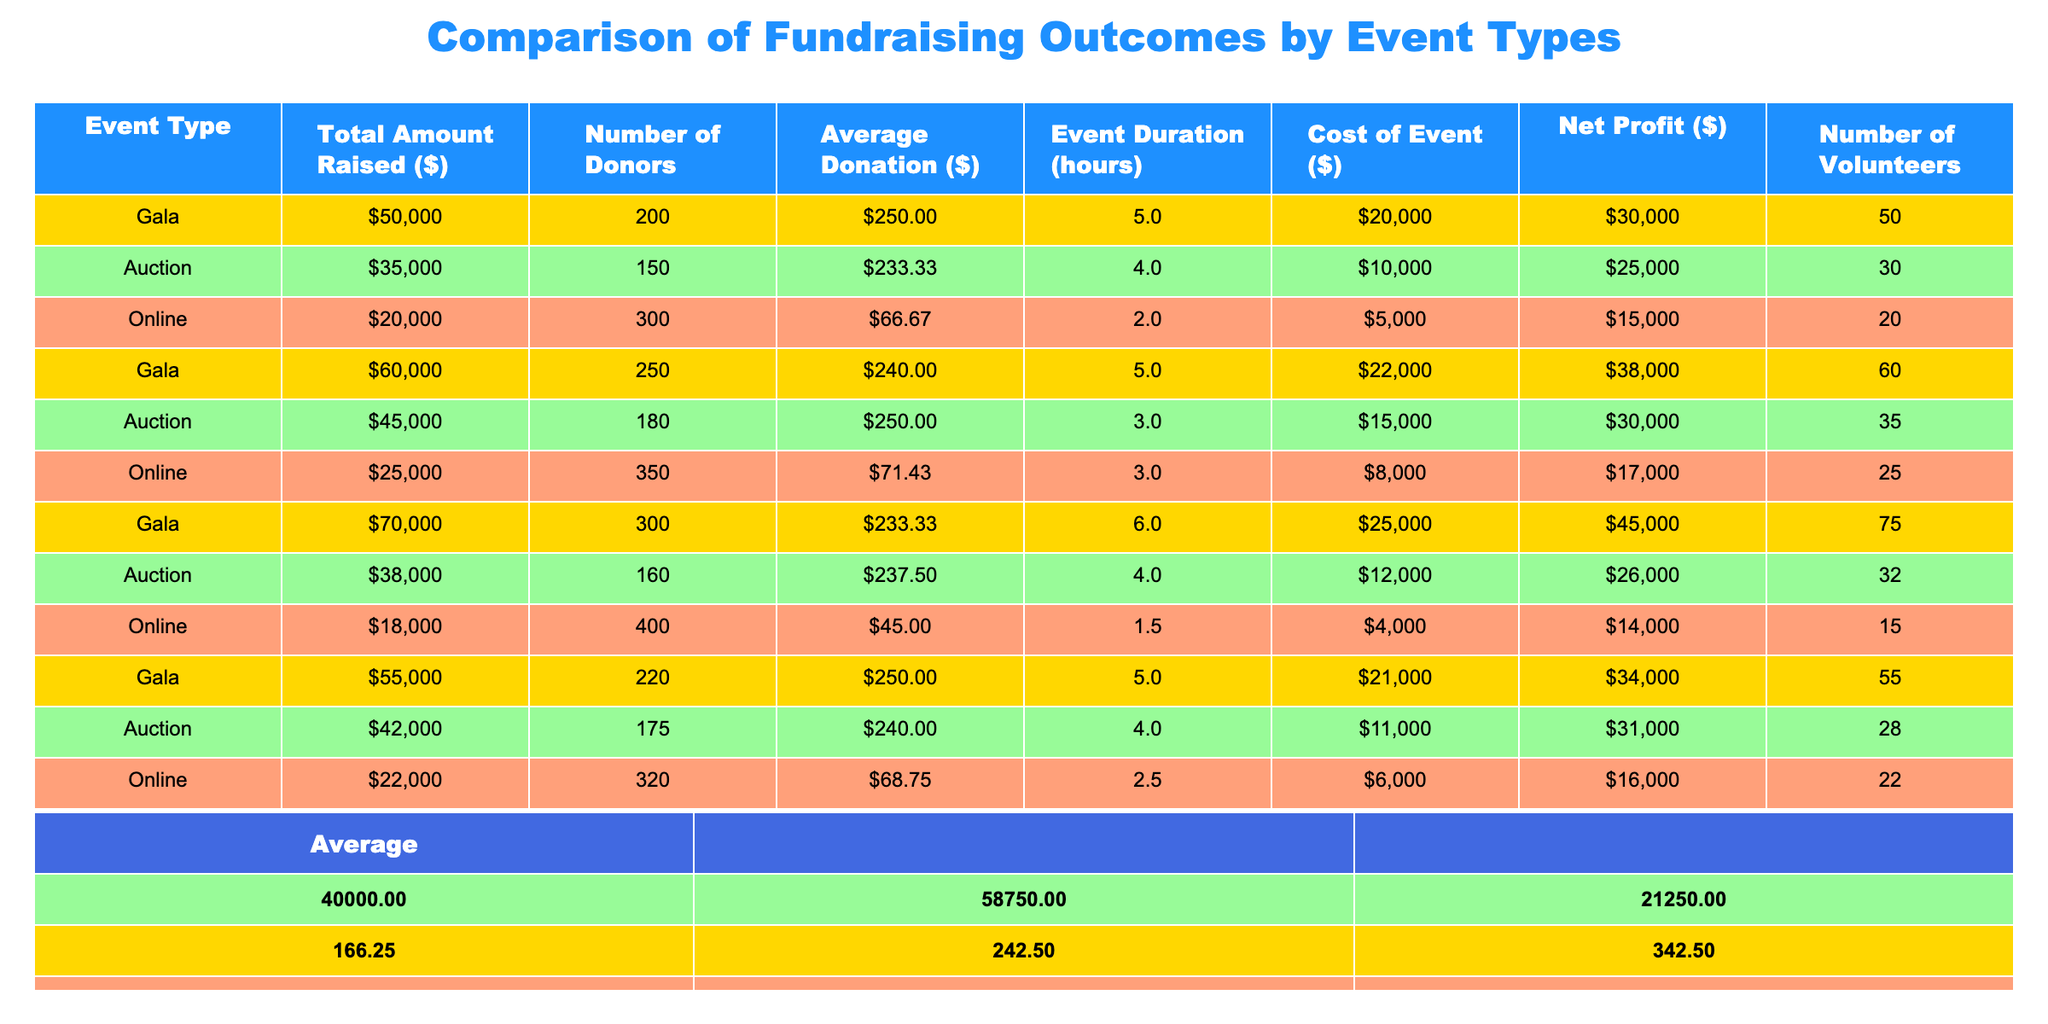What is the total amount raised by the Gala events? From the table, the amounts raised by the Gala events are 50000, 60000, 70000, 55000. Adding these amounts gives us 50000 + 60000 + 70000 + 55000 = 235000.
Answer: 235000 What is the average number of donors for the Auction events? The number of donors for the Auction events are 150, 180, 160, and 175. To find the average, we sum these up: 150 + 180 + 160 + 175 = 665, and then divide by the number of events, which is 4. Therefore, 665 / 4 = 166.25.
Answer: 166.25 Is the average donation amount for the Online events greater than or equal to $70? The average donation amounts for the Online events are 66.67, 71.43, and 68.75. The average of these three values is calculated as (66.67 + 71.43 + 68.75) / 3 = 68.28, which is less than 70.
Answer: No What is the net profit for the Gala events with the highest total amount raised? The Gala event with the highest total amount raised is 70000, which has a net profit of 45000. This can be directly observed from the table.
Answer: 45000 Which event type has the least total amount raised? The total amounts raised by each event type are: Gala (235000), Auction (170000), and Online (83000). The Online event has the least total amount raised, as 83000 is less than the others.
Answer: Online What is the average cost for the Auction events? The costs for the Auction events are 10000, 15000, 12000, and 11000. Sum these costs: 10000 + 15000 + 12000 + 11000 = 48000. Divide by the number of events, which is 4: 48000 / 4 = 12000.
Answer: 12000 What is the difference in total amount raised between the best-performing and the worst-performing event type? The best-performing event type is Gala with a total of 235000, and the worst-performing is Online with 83000. The difference is 235000 - 83000 = 152000.
Answer: 152000 How many total volunteers participated in the Auction events? The number of volunteers for the Auction events are 30, 35, 32, and 28. Adding these gives us 30 + 35 + 32 + 28 = 125 total volunteers.
Answer: 125 Was the average event duration for the Online events shorter than 3 hours? The average durations for the Online events are 2, 3, and 2.5 hours. The average is (2 + 3 + 2.5) / 3 = 2.5, which is less than 3.
Answer: Yes What percentage of the total amount raised by the Gala events can be attributed to its net profit? The total amount raised by Gala events is 235000, and the total net profit is 30000 + 38000 + 45000 + 34000 = 147000. The percentage is (147000 / 235000) * 100 = 62.55%.
Answer: 62.55% 